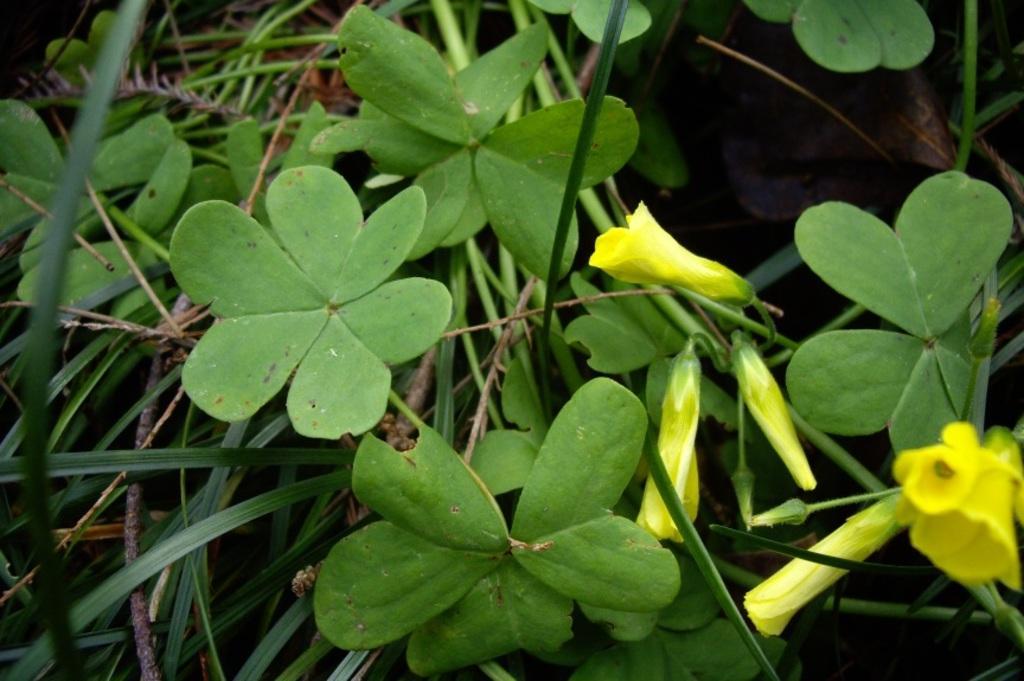In one or two sentences, can you explain what this image depicts? In the image we can see there are plants and in between there are flowers which are in yellow colour. 